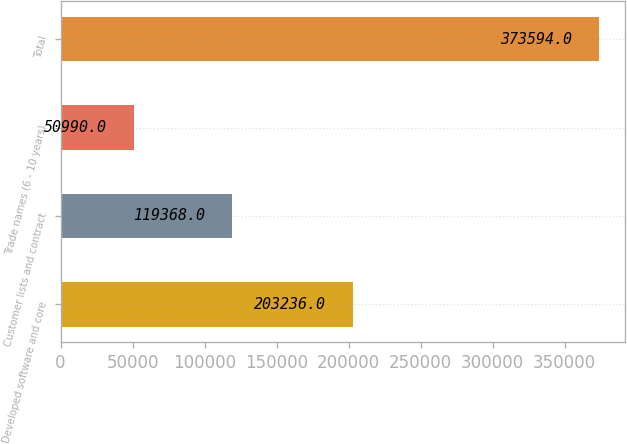Convert chart. <chart><loc_0><loc_0><loc_500><loc_500><bar_chart><fcel>Developed software and core<fcel>Customer lists and contract<fcel>Trade names (6 - 10 years)<fcel>Total<nl><fcel>203236<fcel>119368<fcel>50990<fcel>373594<nl></chart> 